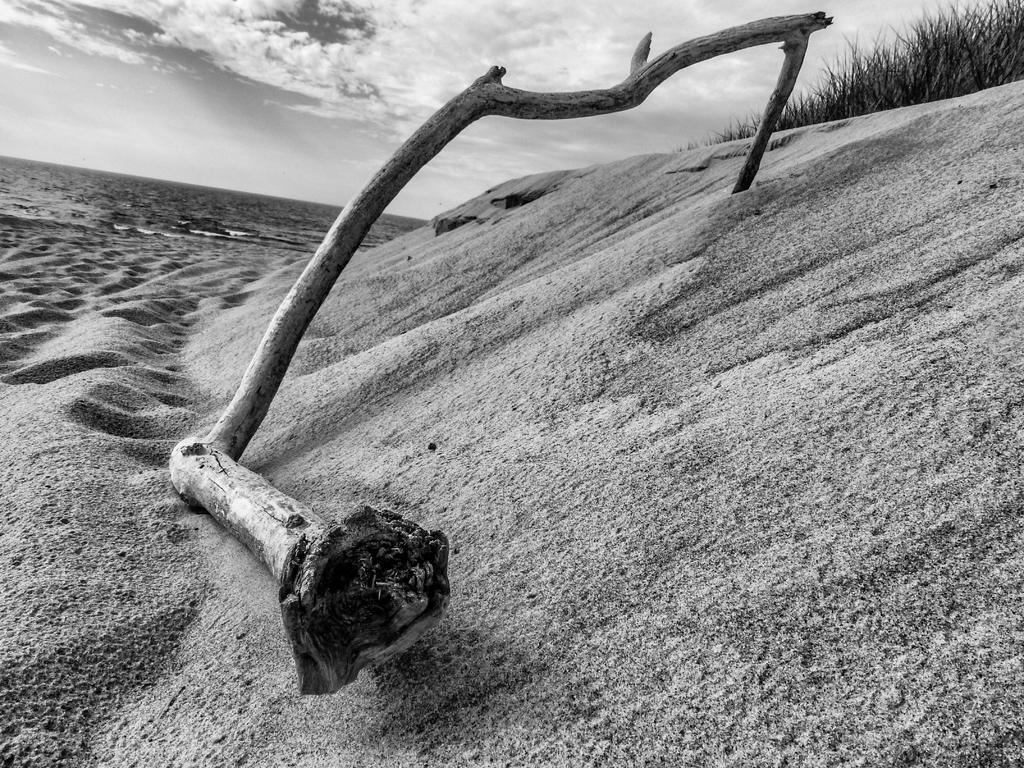What is the main subject in the center of the image? There is a branch of a tree in the center of the image. What can be seen in the background of the image? There is a sea, sand, and sky visible in the background of the image. What is the condition of the sky in the image? The sky has clouds in it. What type of flesh can be seen hanging from the branch in the image? There is no flesh present in the image; it features a branch of a tree. Is there a hook attached to the branch in the image? There is no hook attached to the branch in the image. 